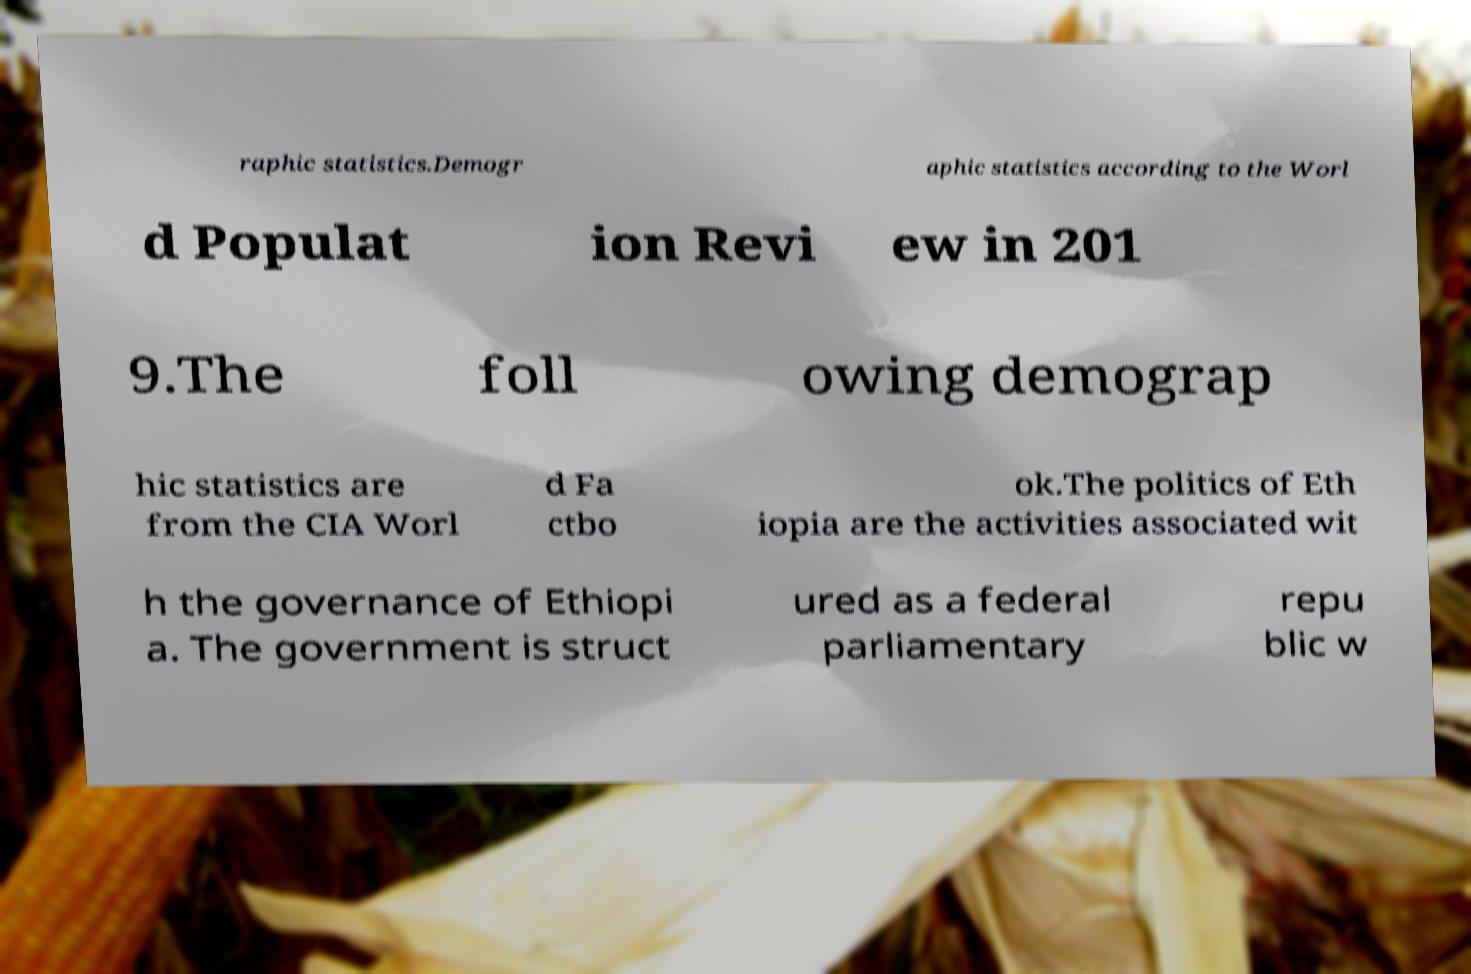What messages or text are displayed in this image? I need them in a readable, typed format. raphic statistics.Demogr aphic statistics according to the Worl d Populat ion Revi ew in 201 9.The foll owing demograp hic statistics are from the CIA Worl d Fa ctbo ok.The politics of Eth iopia are the activities associated wit h the governance of Ethiopi a. The government is struct ured as a federal parliamentary repu blic w 